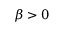<formula> <loc_0><loc_0><loc_500><loc_500>\beta > 0</formula> 